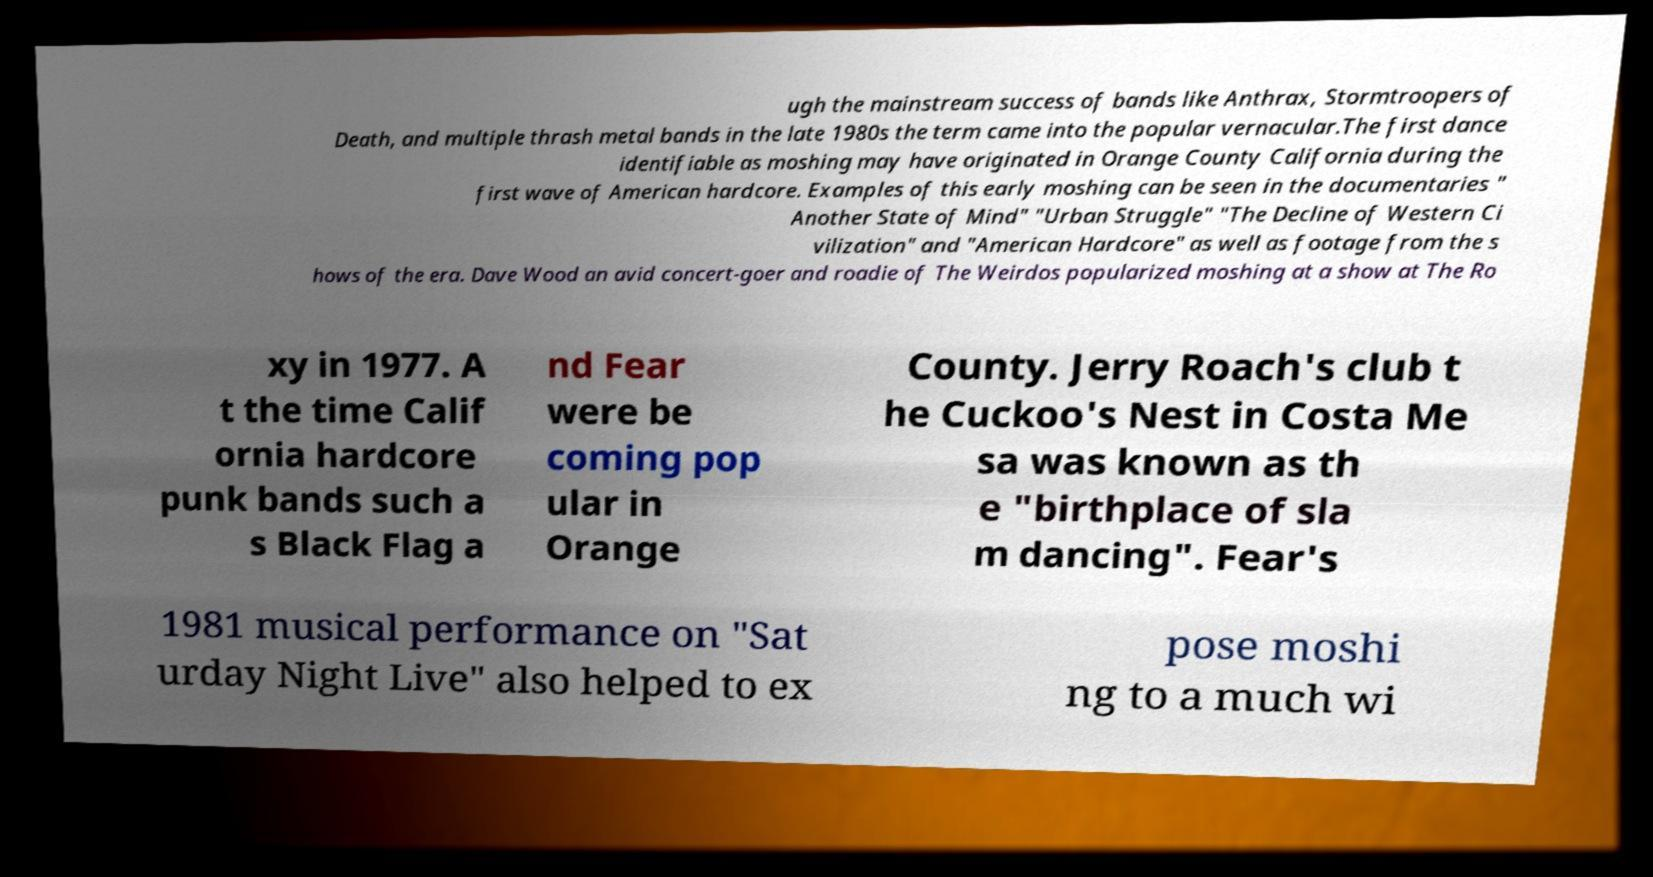There's text embedded in this image that I need extracted. Can you transcribe it verbatim? ugh the mainstream success of bands like Anthrax, Stormtroopers of Death, and multiple thrash metal bands in the late 1980s the term came into the popular vernacular.The first dance identifiable as moshing may have originated in Orange County California during the first wave of American hardcore. Examples of this early moshing can be seen in the documentaries " Another State of Mind" "Urban Struggle" "The Decline of Western Ci vilization" and "American Hardcore" as well as footage from the s hows of the era. Dave Wood an avid concert-goer and roadie of The Weirdos popularized moshing at a show at The Ro xy in 1977. A t the time Calif ornia hardcore punk bands such a s Black Flag a nd Fear were be coming pop ular in Orange County. Jerry Roach's club t he Cuckoo's Nest in Costa Me sa was known as th e "birthplace of sla m dancing". Fear's 1981 musical performance on "Sat urday Night Live" also helped to ex pose moshi ng to a much wi 